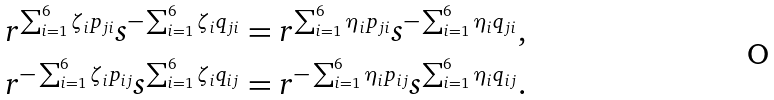Convert formula to latex. <formula><loc_0><loc_0><loc_500><loc_500>r ^ { \sum _ { i = 1 } ^ { 6 } \zeta _ { i } p _ { j i } } s ^ { - \sum _ { i = 1 } ^ { 6 } \zeta _ { i } q _ { j i } } = r ^ { \sum _ { i = 1 } ^ { 6 } \eta _ { i } p _ { j i } } s ^ { - \sum _ { i = 1 } ^ { 6 } \eta _ { i } q _ { j i } } , \\ r ^ { - \sum _ { i = 1 } ^ { 6 } \zeta _ { i } p _ { i j } } s ^ { \sum _ { i = 1 } ^ { 6 } \zeta _ { i } q _ { i j } } = r ^ { - \sum _ { i = 1 } ^ { 6 } \eta _ { i } p _ { i j } } s ^ { \sum _ { i = 1 } ^ { 6 } \eta _ { i } q _ { i j } } .</formula> 